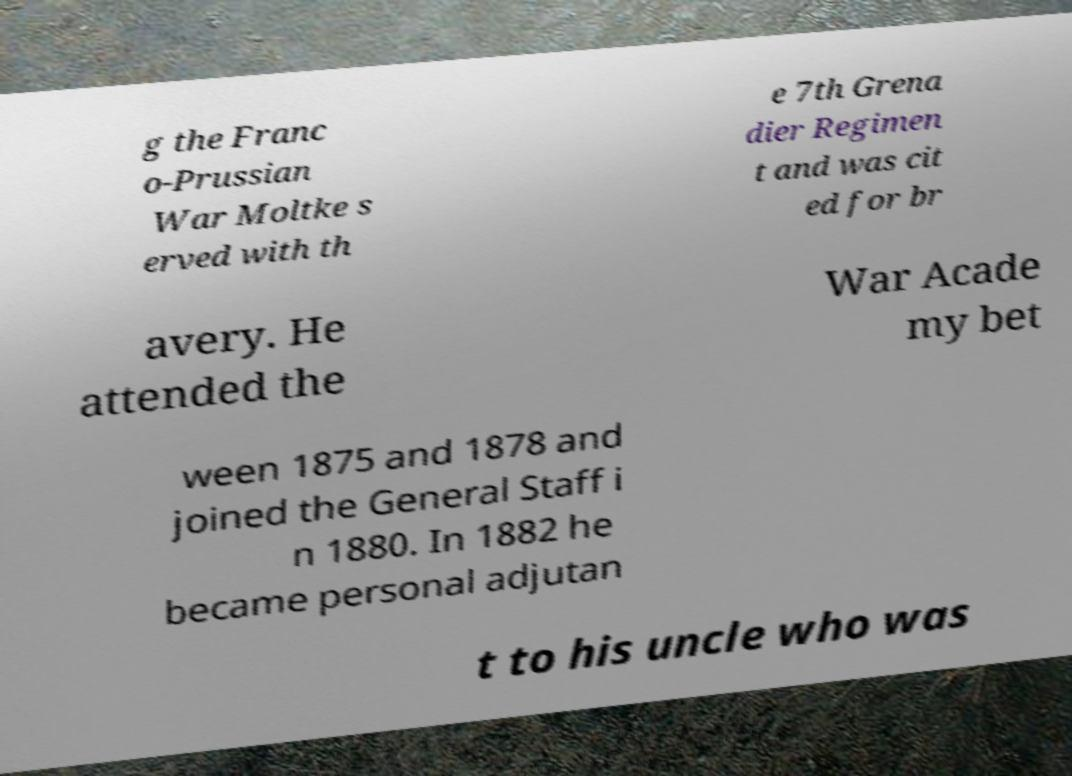For documentation purposes, I need the text within this image transcribed. Could you provide that? g the Franc o-Prussian War Moltke s erved with th e 7th Grena dier Regimen t and was cit ed for br avery. He attended the War Acade my bet ween 1875 and 1878 and joined the General Staff i n 1880. In 1882 he became personal adjutan t to his uncle who was 